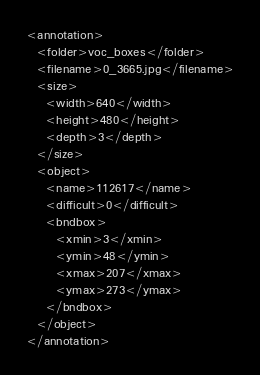<code> <loc_0><loc_0><loc_500><loc_500><_XML_><annotation>
  <folder>voc_boxes</folder>
  <filename>0_3665.jpg</filename>
  <size>
    <width>640</width>
    <height>480</height>
    <depth>3</depth>
  </size>
  <object>
    <name>112617</name>
    <difficult>0</difficult>
    <bndbox>
      <xmin>3</xmin>
      <ymin>48</ymin>
      <xmax>207</xmax>
      <ymax>273</ymax>
    </bndbox>
  </object>
</annotation></code> 